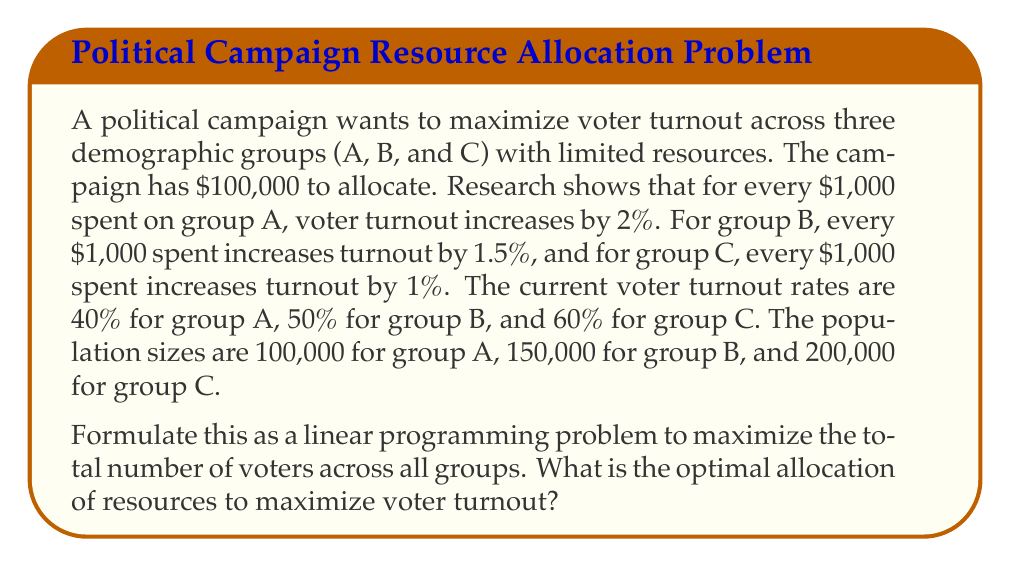Provide a solution to this math problem. To solve this problem, we need to formulate a linear programming model:

Let $x_A$, $x_B$, and $x_C$ be the amount of money (in thousands) allocated to groups A, B, and C respectively.

Objective function:
Maximize total voters = $100,000(0.40 + 0.02x_A) + 150,000(0.50 + 0.015x_B) + 200,000(0.60 + 0.01x_C)$

Constraints:
1. Budget constraint: $x_A + x_B + x_C \leq 100$
2. Non-negativity: $x_A, x_B, x_C \geq 0$

Simplifying the objective function:
Maximize $Z = 2,000x_A + 2,250x_B + 2,000x_C + 220,000$

This is a standard linear programming problem. We can solve it using the simplex method or graphically. The optimal solution will be at one of the corner points of the feasible region.

The corner points are:
(0, 0, 100), (0, 100, 0), (100, 0, 0), (0, 0, 0)

Evaluating Z at each point:
(0, 0, 100): Z = 420,000
(0, 100, 0): Z = 445,000
(100, 0, 0): Z = 420,000
(0, 0, 0): Z = 220,000

The maximum value of Z occurs at (0, 100, 0), which means allocating all $100,000 to group B.
Answer: The optimal allocation is to spend all $100,000 on group B, resulting in a maximum total voter turnout of 445,000 across all groups. 